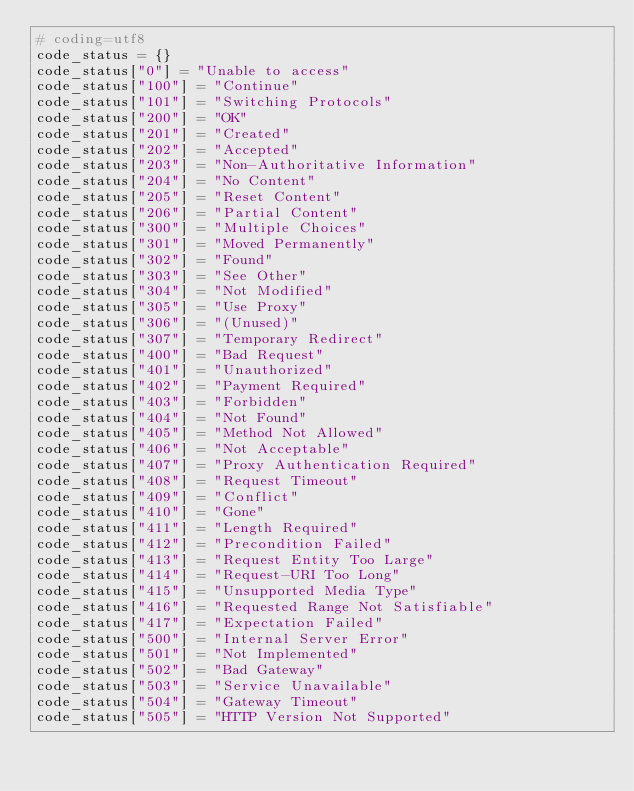<code> <loc_0><loc_0><loc_500><loc_500><_Python_># coding=utf8
code_status = {}
code_status["0"] = "Unable to access"
code_status["100"] = "Continue"
code_status["101"] = "Switching Protocols"
code_status["200"] = "OK"
code_status["201"] = "Created"
code_status["202"] = "Accepted"
code_status["203"] = "Non-Authoritative Information"
code_status["204"] = "No Content"
code_status["205"] = "Reset Content"
code_status["206"] = "Partial Content"
code_status["300"] = "Multiple Choices"
code_status["301"] = "Moved Permanently"
code_status["302"] = "Found"
code_status["303"] = "See Other"
code_status["304"] = "Not Modified"
code_status["305"] = "Use Proxy"
code_status["306"] = "(Unused)"
code_status["307"] = "Temporary Redirect"
code_status["400"] = "Bad Request"
code_status["401"] = "Unauthorized"
code_status["402"] = "Payment Required"
code_status["403"] = "Forbidden"
code_status["404"] = "Not Found"
code_status["405"] = "Method Not Allowed"
code_status["406"] = "Not Acceptable"
code_status["407"] = "Proxy Authentication Required"
code_status["408"] = "Request Timeout"
code_status["409"] = "Conflict"
code_status["410"] = "Gone"
code_status["411"] = "Length Required"
code_status["412"] = "Precondition Failed"
code_status["413"] = "Request Entity Too Large"
code_status["414"] = "Request-URI Too Long"
code_status["415"] = "Unsupported Media Type"
code_status["416"] = "Requested Range Not Satisfiable"
code_status["417"] = "Expectation Failed"
code_status["500"] = "Internal Server Error"
code_status["501"] = "Not Implemented"
code_status["502"] = "Bad Gateway"
code_status["503"] = "Service Unavailable"
code_status["504"] = "Gateway Timeout"
code_status["505"] = "HTTP Version Not Supported"</code> 